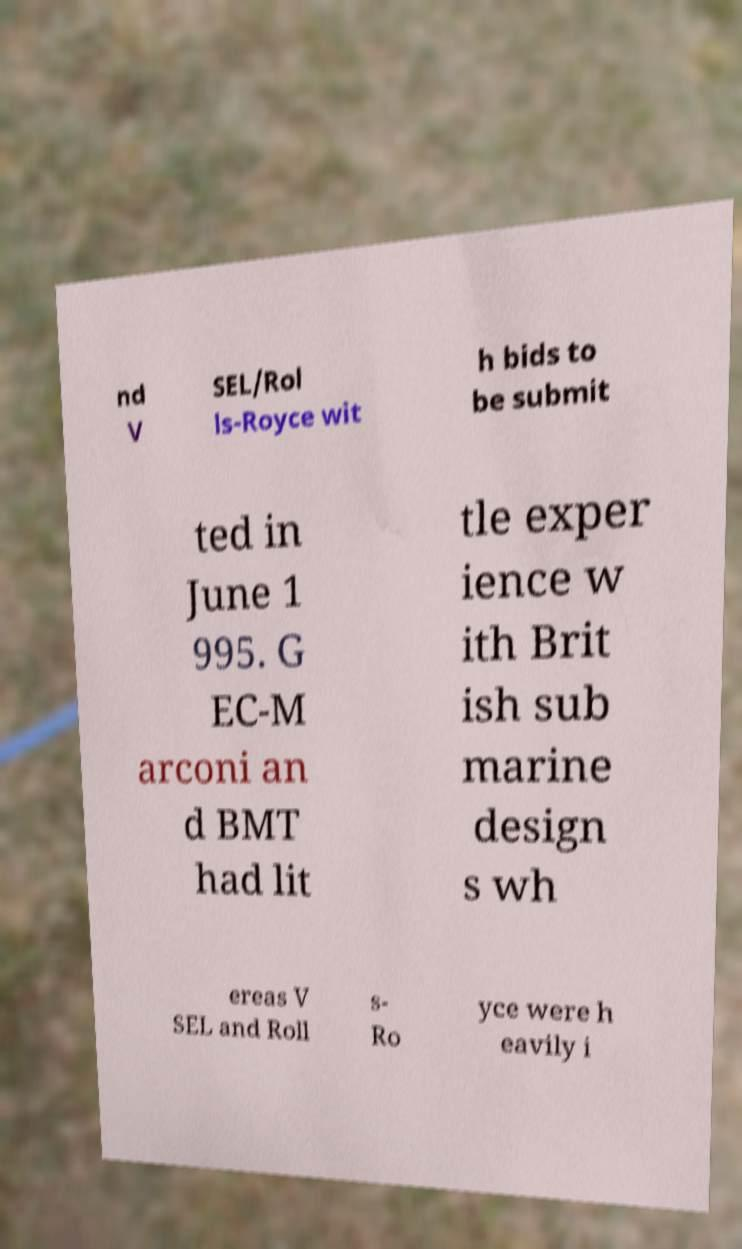Please identify and transcribe the text found in this image. nd V SEL/Rol ls-Royce wit h bids to be submit ted in June 1 995. G EC-M arconi an d BMT had lit tle exper ience w ith Brit ish sub marine design s wh ereas V SEL and Roll s- Ro yce were h eavily i 